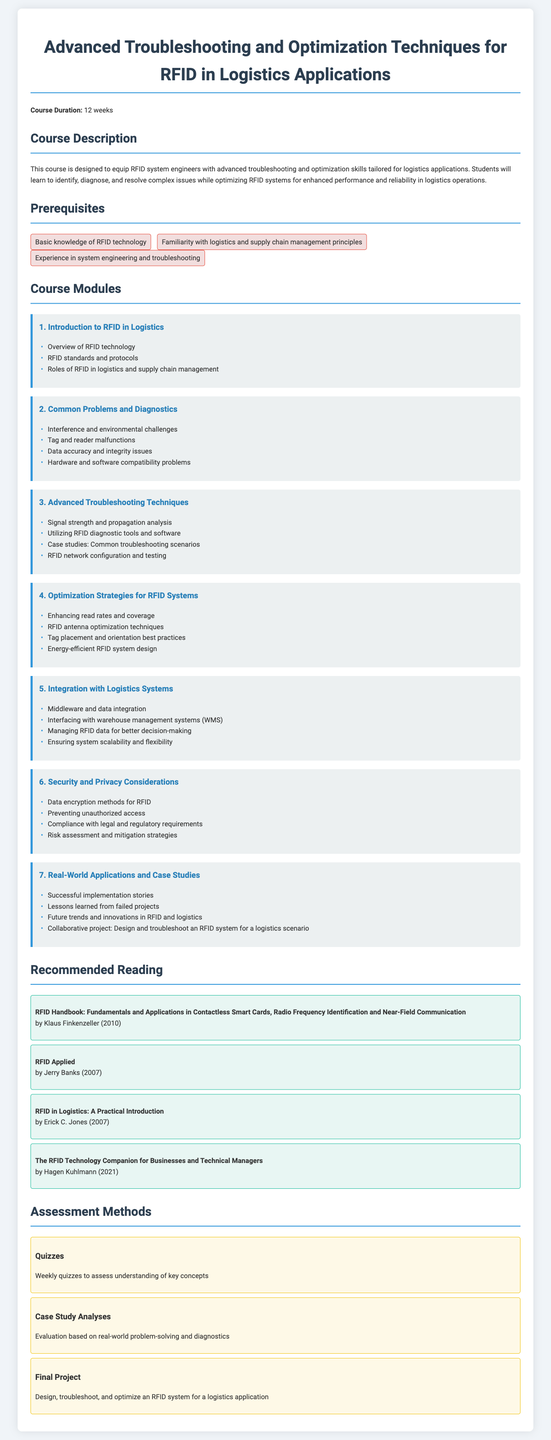What is the course duration? The course duration is explicitly stated in the document as "12 weeks."
Answer: 12 weeks Who is the author of the "RFID Handbook"? The author of the "RFID Handbook" is mentioned in the recommended reading section as Klaus Finkenzeller.
Answer: Klaus Finkenzeller What type of assessments are included in the course? The assessments include quizzes, case study analyses, and a final project, which are explicitly listed in the document.
Answer: Quizzes, case study analyses, final project What is the focus of the 'Optimization Strategies for RFID Systems' module? The module focuses on enhancing read rates, RFID antenna optimization, tag placement, and energy-efficient design, as outlined in the document.
Answer: Enhancing read rates and coverage What are the prerequisites for the course? The prerequisites listed include basic knowledge of RFID technology, familiarity with logistics principles, and experience in system engineering.
Answer: Basic knowledge of RFID technology, familiarity with logistics and supply chain management principles, experience in system engineering and troubleshooting What is covered in the module titled 'Security and Privacy Considerations'? This module covers data encryption methods, preventing unauthorized access, compliance requirements, and risk assessment strategies.
Answer: Data encryption methods for RFID, preventing unauthorized access, compliance with legal and regulatory requirements, risk assessment and mitigation strategies 